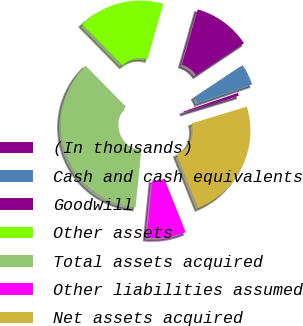Convert chart. <chart><loc_0><loc_0><loc_500><loc_500><pie_chart><fcel>(In thousands)<fcel>Cash and cash equivalents<fcel>Goodwill<fcel>Other assets<fcel>Total assets acquired<fcel>Other liabilities assumed<fcel>Net assets acquired<nl><fcel>0.56%<fcel>4.11%<fcel>11.2%<fcel>16.82%<fcel>36.03%<fcel>7.65%<fcel>23.64%<nl></chart> 